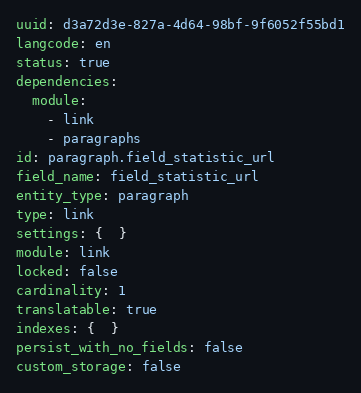<code> <loc_0><loc_0><loc_500><loc_500><_YAML_>uuid: d3a72d3e-827a-4d64-98bf-9f6052f55bd1
langcode: en
status: true
dependencies:
  module:
    - link
    - paragraphs
id: paragraph.field_statistic_url
field_name: field_statistic_url
entity_type: paragraph
type: link
settings: {  }
module: link
locked: false
cardinality: 1
translatable: true
indexes: {  }
persist_with_no_fields: false
custom_storage: false
</code> 